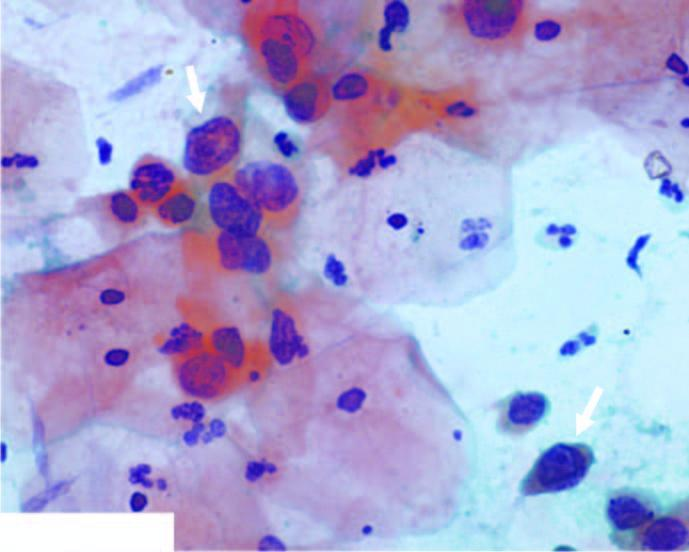do many of the hepatocytes have scanty cytoplasm and markedly hyperchromatic nuclei having irregular nuclear outlines?
Answer the question using a single word or phrase. No 